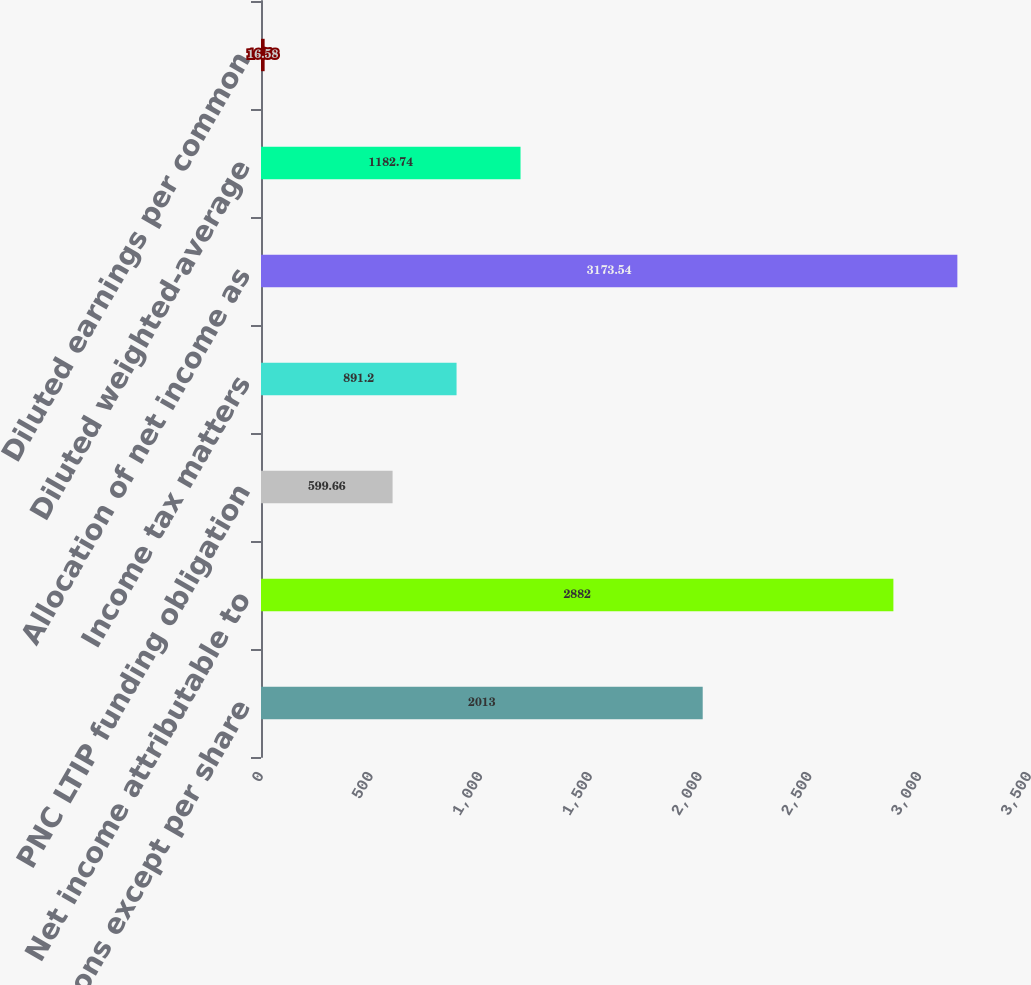Convert chart to OTSL. <chart><loc_0><loc_0><loc_500><loc_500><bar_chart><fcel>(in millions except per share<fcel>Net income attributable to<fcel>PNC LTIP funding obligation<fcel>Income tax matters<fcel>Allocation of net income as<fcel>Diluted weighted-average<fcel>Diluted earnings per common<nl><fcel>2013<fcel>2882<fcel>599.66<fcel>891.2<fcel>3173.54<fcel>1182.74<fcel>16.58<nl></chart> 